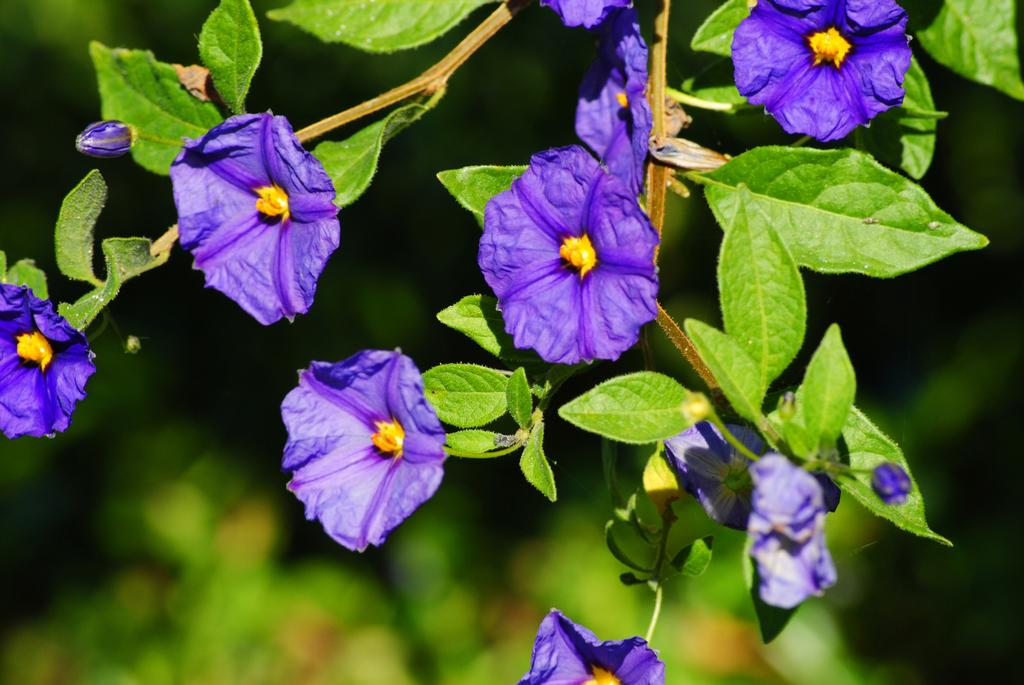What type of plants can be seen in the image? There are flowers and trees in the image. Can you describe the setting in which the plants are located? The image features a natural setting with both flowers and trees. How many cherries are hanging from the trees in the image? There are no cherries present in the image; it features flowers and trees. What is the comparison between the crib and the flowers in the image? There is no crib present in the image, so it is not possible to make a comparison between the crib and the flowers. 